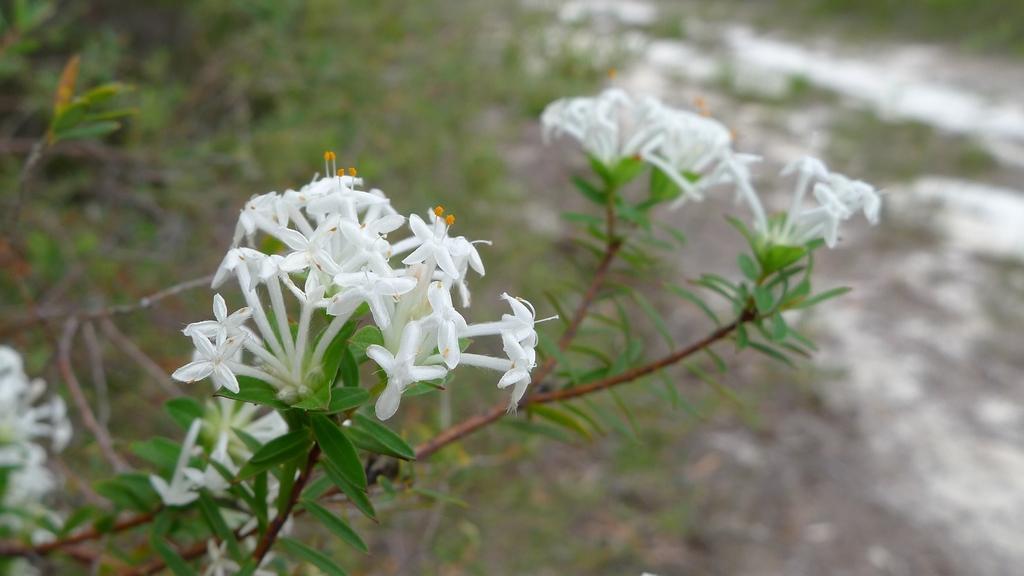Could you give a brief overview of what you see in this image? In this picture we can see plants with flowers and in the background we can see the grass and it is blurry. 